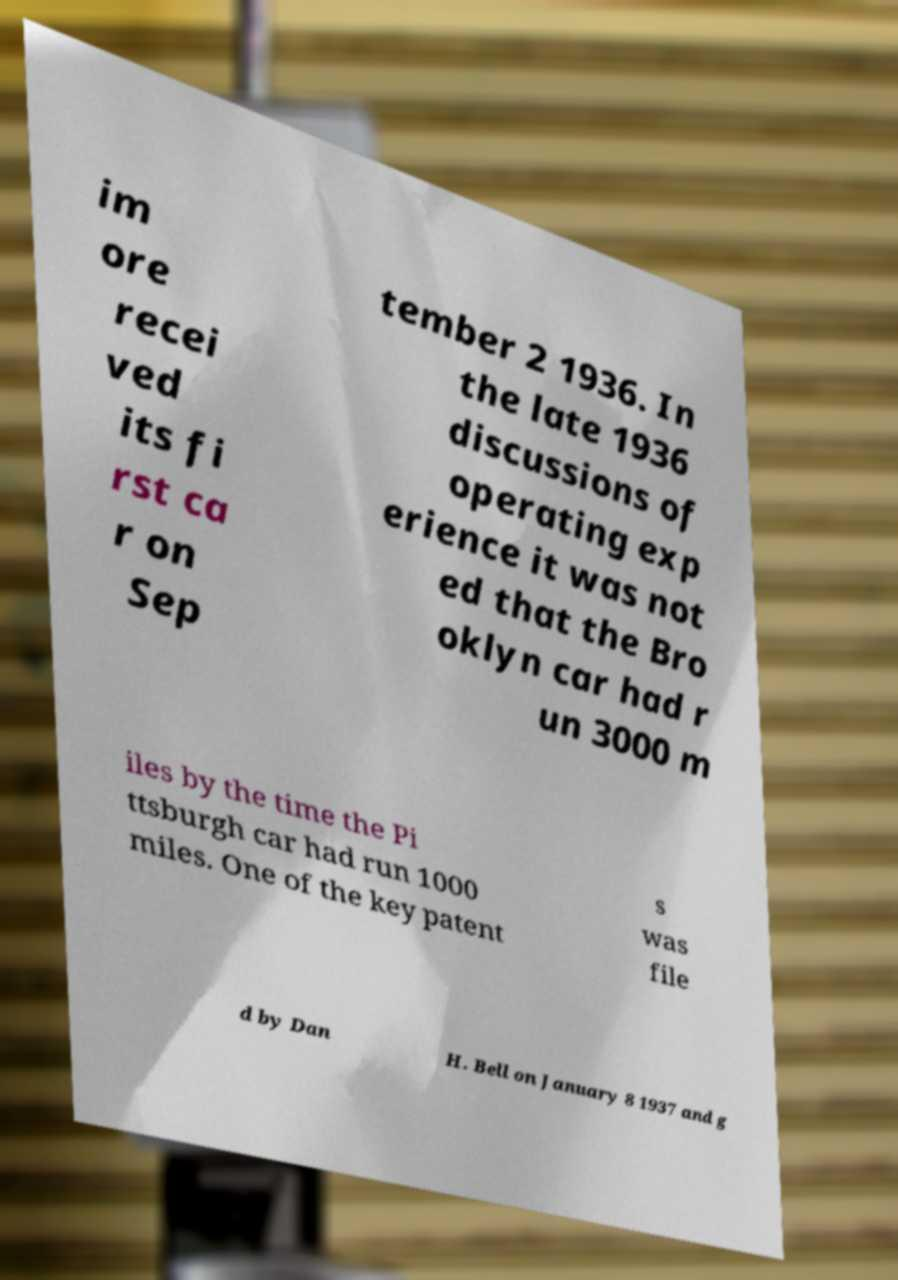Please identify and transcribe the text found in this image. im ore recei ved its fi rst ca r on Sep tember 2 1936. In the late 1936 discussions of operating exp erience it was not ed that the Bro oklyn car had r un 3000 m iles by the time the Pi ttsburgh car had run 1000 miles. One of the key patent s was file d by Dan H. Bell on January 8 1937 and g 